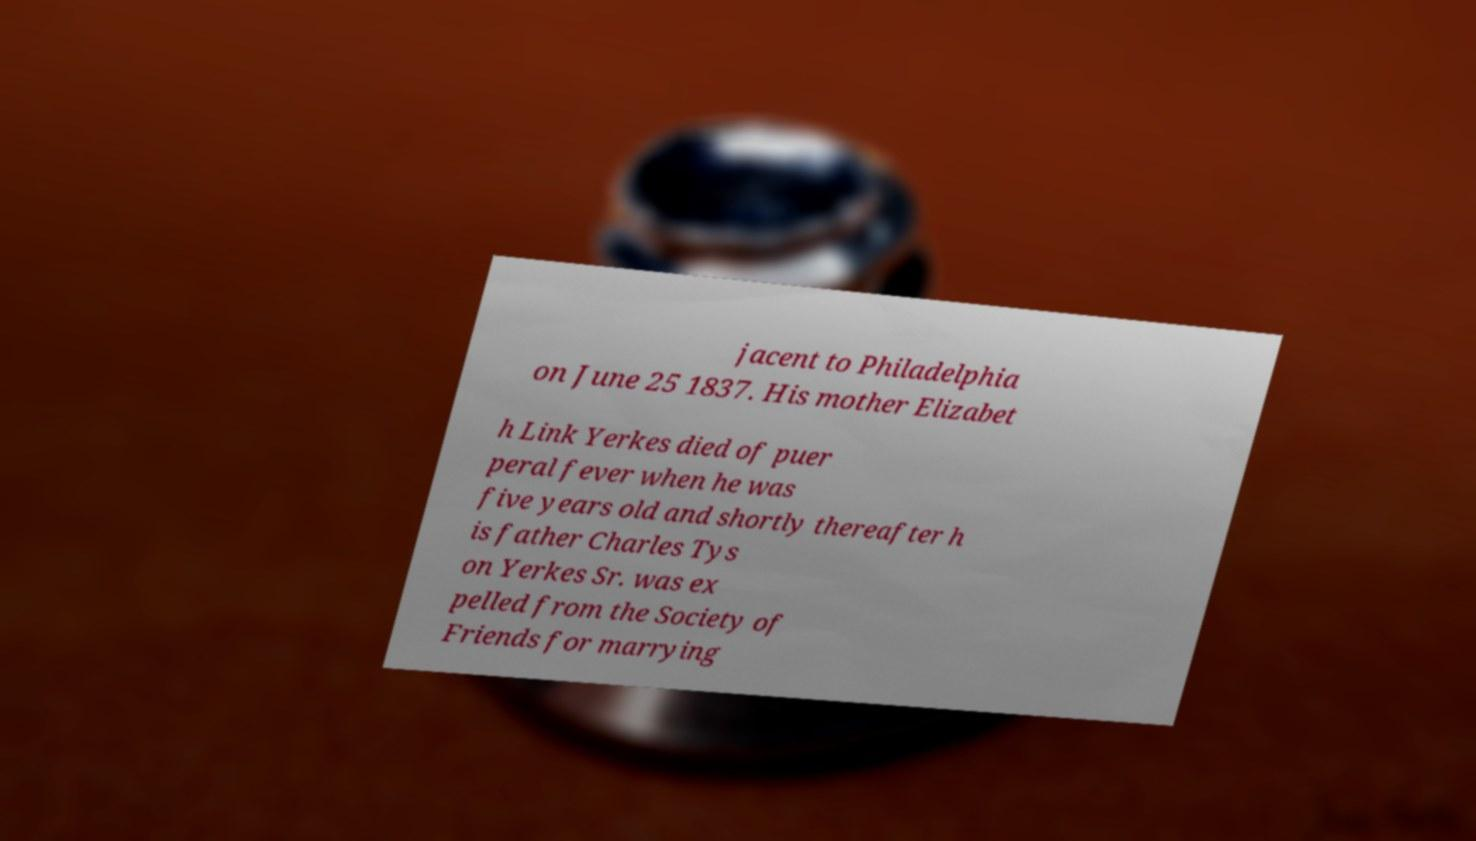Can you accurately transcribe the text from the provided image for me? jacent to Philadelphia on June 25 1837. His mother Elizabet h Link Yerkes died of puer peral fever when he was five years old and shortly thereafter h is father Charles Tys on Yerkes Sr. was ex pelled from the Society of Friends for marrying 